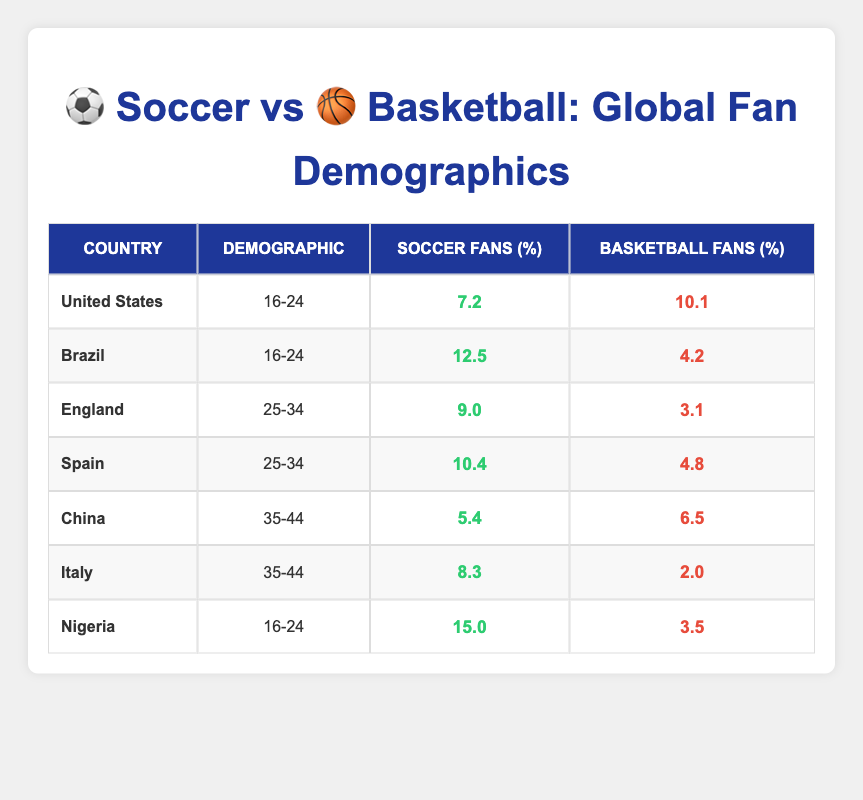What percentage of basketball fans in Brazil is lower than that of soccer fans? The table indicates that the percentage of basketball fans in Brazil is 4.2 while soccer fans account for 12.5. Since 4.2 is lower than 12.5, the statement is correct.
Answer: Yes What is the total percentage of soccer fans aged 16-24 across the United States, Brazil, and Nigeria? From the table, the percentages for soccer fans aged 16-24 are: United States 7.2, Brazil 12.5, and Nigeria 15.0. Adding these gives: 7.2 + 12.5 + 15.0 = 34.7.
Answer: 34.7 Which country has the highest percentage of soccer fans in the 16-24 demographic? Checking the table for the 16-24 demographic, Nigeria has the highest percentage of soccer fans at 15.0, compared to Brazil (12.5) and the United States (7.2).
Answer: Nigeria What is the average percentage of basketball fans aged 25-34 in England and Spain? In England, the percentage of basketball fans is 3.1, while in Spain it is 4.8. The average is calculated by adding these percentages (3.1 + 4.8 = 7.9) and dividing by 2, resulting in 7.9 / 2 = 3.95.
Answer: 3.95 Are there more soccer fans aged 35-44 in Italy compared to basketball fans in the same age group in China? In the table, Italy has 8.3% soccer fans while China has 6.5% basketball fans. Since 8.3 is greater than 6.5, the statement is true.
Answer: Yes What percentage of soccer fans do Spain have compared to basketball fans in the same age bracket? For the 25-34 demographic in Spain, soccer fans account for 10.4% while basketball fans account for 4.8%. Therefore, the percentage of soccer fans in Spain is higher than that of basketball fans.
Answer: Soccer fans are higher Which sport has more fans aged 35-44 in Italy? The table shows that soccer fans amount to 8.3% while basketball fans are only 2.0%. Therefore, soccer has more fans in this demographic.
Answer: Soccer What is the difference in the percentage of fans in the 25-34 age group between soccer and basketball in Spain? In Spain, soccer fans account for 10.4% and basketball fans for 4.8%. The difference is 10.4 - 4.8 = 5.6%.
Answer: 5.6 